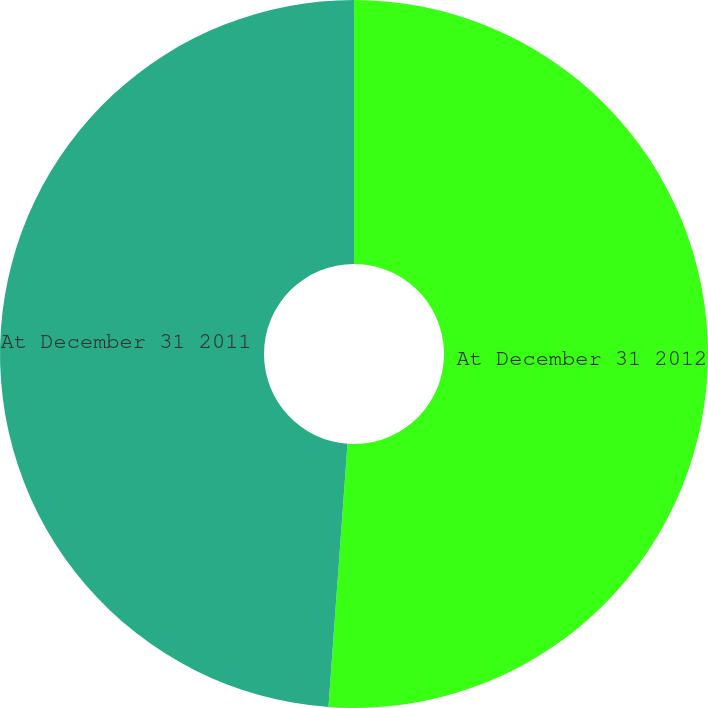<chart> <loc_0><loc_0><loc_500><loc_500><pie_chart><fcel>At December 31 2012<fcel>At December 31 2011<nl><fcel>51.15%<fcel>48.85%<nl></chart> 